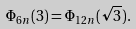<formula> <loc_0><loc_0><loc_500><loc_500>\Phi _ { 6 n } ( 3 ) = \Phi _ { 1 2 n } ( \sqrt { 3 } ) .</formula> 